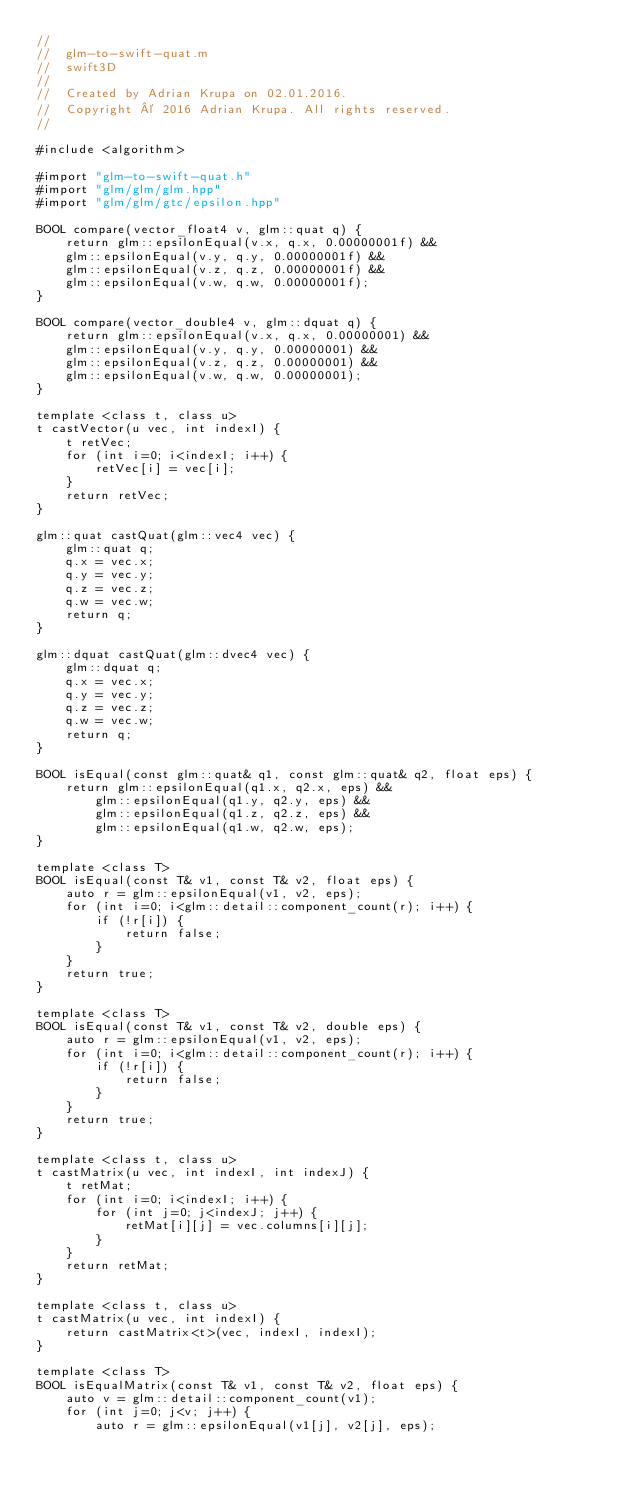<code> <loc_0><loc_0><loc_500><loc_500><_ObjectiveC_>//
//  glm-to-swift-quat.m
//  swift3D
//
//  Created by Adrian Krupa on 02.01.2016.
//  Copyright © 2016 Adrian Krupa. All rights reserved.
//

#include <algorithm>

#import "glm-to-swift-quat.h"
#import "glm/glm/glm.hpp"
#import "glm/glm/gtc/epsilon.hpp"

BOOL compare(vector_float4 v, glm::quat q) {
    return glm::epsilonEqual(v.x, q.x, 0.00000001f) &&
    glm::epsilonEqual(v.y, q.y, 0.00000001f) &&
    glm::epsilonEqual(v.z, q.z, 0.00000001f) &&
    glm::epsilonEqual(v.w, q.w, 0.00000001f);
}

BOOL compare(vector_double4 v, glm::dquat q) {
    return glm::epsilonEqual(v.x, q.x, 0.00000001) &&
    glm::epsilonEqual(v.y, q.y, 0.00000001) &&
    glm::epsilonEqual(v.z, q.z, 0.00000001) &&
    glm::epsilonEqual(v.w, q.w, 0.00000001);
}

template <class t, class u>
t castVector(u vec, int indexI) {
    t retVec;
    for (int i=0; i<indexI; i++) {
        retVec[i] = vec[i];
    }
    return retVec;
}

glm::quat castQuat(glm::vec4 vec) {
    glm::quat q;
    q.x = vec.x;
    q.y = vec.y;
    q.z = vec.z;
    q.w = vec.w;
    return q;
}

glm::dquat castQuat(glm::dvec4 vec) {
    glm::dquat q;
    q.x = vec.x;
    q.y = vec.y;
    q.z = vec.z;
    q.w = vec.w;
    return q;
}

BOOL isEqual(const glm::quat& q1, const glm::quat& q2, float eps) {
    return glm::epsilonEqual(q1.x, q2.x, eps) &&
        glm::epsilonEqual(q1.y, q2.y, eps) &&
        glm::epsilonEqual(q1.z, q2.z, eps) &&
        glm::epsilonEqual(q1.w, q2.w, eps);
}

template <class T>
BOOL isEqual(const T& v1, const T& v2, float eps) {
    auto r = glm::epsilonEqual(v1, v2, eps);
    for (int i=0; i<glm::detail::component_count(r); i++) {
        if (!r[i]) {
            return false;
        }
    }
    return true;
}

template <class T>
BOOL isEqual(const T& v1, const T& v2, double eps) {
    auto r = glm::epsilonEqual(v1, v2, eps);
    for (int i=0; i<glm::detail::component_count(r); i++) {
        if (!r[i]) {
            return false;
        }
    }
    return true;
}

template <class t, class u>
t castMatrix(u vec, int indexI, int indexJ) {
    t retMat;
    for (int i=0; i<indexI; i++) {
        for (int j=0; j<indexJ; j++) {
            retMat[i][j] = vec.columns[i][j];
        }
    }
    return retMat;
}

template <class t, class u>
t castMatrix(u vec, int indexI) {
    return castMatrix<t>(vec, indexI, indexI);
}

template <class T>
BOOL isEqualMatrix(const T& v1, const T& v2, float eps) {
    auto v = glm::detail::component_count(v1);
    for (int j=0; j<v; j++) {
        auto r = glm::epsilonEqual(v1[j], v2[j], eps);</code> 